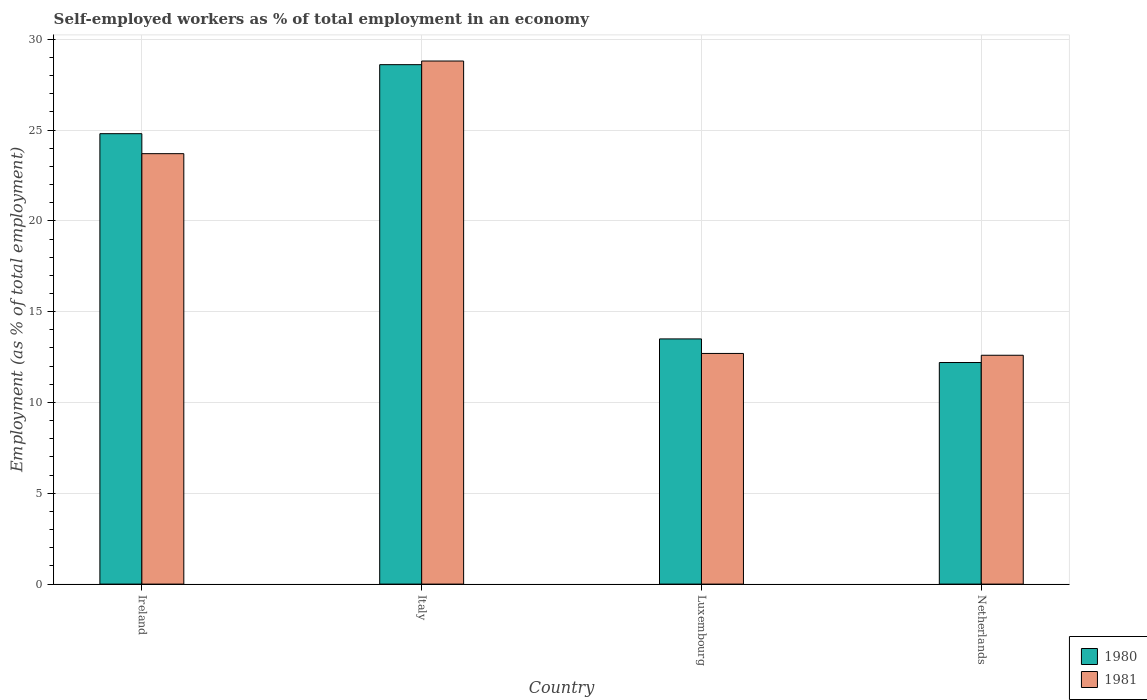How many different coloured bars are there?
Your response must be concise. 2. Are the number of bars on each tick of the X-axis equal?
Your response must be concise. Yes. How many bars are there on the 3rd tick from the left?
Provide a short and direct response. 2. How many bars are there on the 4th tick from the right?
Your answer should be very brief. 2. In how many cases, is the number of bars for a given country not equal to the number of legend labels?
Provide a short and direct response. 0. What is the percentage of self-employed workers in 1980 in Netherlands?
Give a very brief answer. 12.2. Across all countries, what is the maximum percentage of self-employed workers in 1980?
Offer a terse response. 28.6. Across all countries, what is the minimum percentage of self-employed workers in 1981?
Ensure brevity in your answer.  12.6. In which country was the percentage of self-employed workers in 1981 maximum?
Offer a very short reply. Italy. What is the total percentage of self-employed workers in 1981 in the graph?
Your response must be concise. 77.8. What is the difference between the percentage of self-employed workers in 1980 in Ireland and that in Luxembourg?
Your answer should be very brief. 11.3. What is the difference between the percentage of self-employed workers in 1981 in Luxembourg and the percentage of self-employed workers in 1980 in Ireland?
Keep it short and to the point. -12.1. What is the average percentage of self-employed workers in 1981 per country?
Make the answer very short. 19.45. What is the difference between the percentage of self-employed workers of/in 1980 and percentage of self-employed workers of/in 1981 in Ireland?
Provide a short and direct response. 1.1. In how many countries, is the percentage of self-employed workers in 1980 greater than 9 %?
Your answer should be very brief. 4. What is the ratio of the percentage of self-employed workers in 1980 in Italy to that in Luxembourg?
Offer a terse response. 2.12. Is the percentage of self-employed workers in 1980 in Ireland less than that in Netherlands?
Your answer should be very brief. No. Is the difference between the percentage of self-employed workers in 1980 in Luxembourg and Netherlands greater than the difference between the percentage of self-employed workers in 1981 in Luxembourg and Netherlands?
Provide a short and direct response. Yes. What is the difference between the highest and the second highest percentage of self-employed workers in 1981?
Offer a very short reply. 16.1. What is the difference between the highest and the lowest percentage of self-employed workers in 1980?
Your answer should be very brief. 16.4. Is the sum of the percentage of self-employed workers in 1980 in Luxembourg and Netherlands greater than the maximum percentage of self-employed workers in 1981 across all countries?
Offer a very short reply. No. What does the 1st bar from the right in Italy represents?
Ensure brevity in your answer.  1981. How many bars are there?
Offer a terse response. 8. Are all the bars in the graph horizontal?
Offer a terse response. No. How are the legend labels stacked?
Keep it short and to the point. Vertical. What is the title of the graph?
Your response must be concise. Self-employed workers as % of total employment in an economy. Does "2009" appear as one of the legend labels in the graph?
Provide a succinct answer. No. What is the label or title of the Y-axis?
Provide a succinct answer. Employment (as % of total employment). What is the Employment (as % of total employment) of 1980 in Ireland?
Your response must be concise. 24.8. What is the Employment (as % of total employment) of 1981 in Ireland?
Ensure brevity in your answer.  23.7. What is the Employment (as % of total employment) of 1980 in Italy?
Your response must be concise. 28.6. What is the Employment (as % of total employment) in 1981 in Italy?
Keep it short and to the point. 28.8. What is the Employment (as % of total employment) in 1980 in Luxembourg?
Provide a succinct answer. 13.5. What is the Employment (as % of total employment) of 1981 in Luxembourg?
Your answer should be very brief. 12.7. What is the Employment (as % of total employment) in 1980 in Netherlands?
Your response must be concise. 12.2. What is the Employment (as % of total employment) in 1981 in Netherlands?
Give a very brief answer. 12.6. Across all countries, what is the maximum Employment (as % of total employment) in 1980?
Offer a very short reply. 28.6. Across all countries, what is the maximum Employment (as % of total employment) in 1981?
Offer a very short reply. 28.8. Across all countries, what is the minimum Employment (as % of total employment) in 1980?
Your answer should be compact. 12.2. Across all countries, what is the minimum Employment (as % of total employment) in 1981?
Offer a terse response. 12.6. What is the total Employment (as % of total employment) of 1980 in the graph?
Provide a succinct answer. 79.1. What is the total Employment (as % of total employment) in 1981 in the graph?
Give a very brief answer. 77.8. What is the difference between the Employment (as % of total employment) in 1981 in Ireland and that in Italy?
Provide a succinct answer. -5.1. What is the difference between the Employment (as % of total employment) in 1980 in Ireland and that in Luxembourg?
Your answer should be compact. 11.3. What is the difference between the Employment (as % of total employment) of 1980 in Ireland and that in Netherlands?
Ensure brevity in your answer.  12.6. What is the difference between the Employment (as % of total employment) of 1980 in Italy and that in Luxembourg?
Ensure brevity in your answer.  15.1. What is the difference between the Employment (as % of total employment) in 1981 in Italy and that in Luxembourg?
Give a very brief answer. 16.1. What is the difference between the Employment (as % of total employment) of 1980 in Italy and that in Netherlands?
Make the answer very short. 16.4. What is the difference between the Employment (as % of total employment) in 1980 in Luxembourg and that in Netherlands?
Provide a succinct answer. 1.3. What is the difference between the Employment (as % of total employment) in 1980 in Ireland and the Employment (as % of total employment) in 1981 in Luxembourg?
Your answer should be compact. 12.1. What is the difference between the Employment (as % of total employment) in 1980 in Ireland and the Employment (as % of total employment) in 1981 in Netherlands?
Give a very brief answer. 12.2. What is the difference between the Employment (as % of total employment) of 1980 in Italy and the Employment (as % of total employment) of 1981 in Luxembourg?
Your answer should be very brief. 15.9. What is the difference between the Employment (as % of total employment) in 1980 in Italy and the Employment (as % of total employment) in 1981 in Netherlands?
Offer a very short reply. 16. What is the average Employment (as % of total employment) of 1980 per country?
Provide a succinct answer. 19.77. What is the average Employment (as % of total employment) in 1981 per country?
Keep it short and to the point. 19.45. What is the difference between the Employment (as % of total employment) in 1980 and Employment (as % of total employment) in 1981 in Ireland?
Your answer should be very brief. 1.1. What is the ratio of the Employment (as % of total employment) in 1980 in Ireland to that in Italy?
Ensure brevity in your answer.  0.87. What is the ratio of the Employment (as % of total employment) of 1981 in Ireland to that in Italy?
Ensure brevity in your answer.  0.82. What is the ratio of the Employment (as % of total employment) in 1980 in Ireland to that in Luxembourg?
Offer a terse response. 1.84. What is the ratio of the Employment (as % of total employment) of 1981 in Ireland to that in Luxembourg?
Your answer should be very brief. 1.87. What is the ratio of the Employment (as % of total employment) in 1980 in Ireland to that in Netherlands?
Make the answer very short. 2.03. What is the ratio of the Employment (as % of total employment) of 1981 in Ireland to that in Netherlands?
Your answer should be very brief. 1.88. What is the ratio of the Employment (as % of total employment) of 1980 in Italy to that in Luxembourg?
Your answer should be very brief. 2.12. What is the ratio of the Employment (as % of total employment) of 1981 in Italy to that in Luxembourg?
Give a very brief answer. 2.27. What is the ratio of the Employment (as % of total employment) of 1980 in Italy to that in Netherlands?
Your answer should be compact. 2.34. What is the ratio of the Employment (as % of total employment) in 1981 in Italy to that in Netherlands?
Your answer should be very brief. 2.29. What is the ratio of the Employment (as % of total employment) of 1980 in Luxembourg to that in Netherlands?
Your response must be concise. 1.11. What is the ratio of the Employment (as % of total employment) of 1981 in Luxembourg to that in Netherlands?
Your answer should be very brief. 1.01. What is the difference between the highest and the lowest Employment (as % of total employment) in 1980?
Provide a succinct answer. 16.4. What is the difference between the highest and the lowest Employment (as % of total employment) of 1981?
Provide a succinct answer. 16.2. 